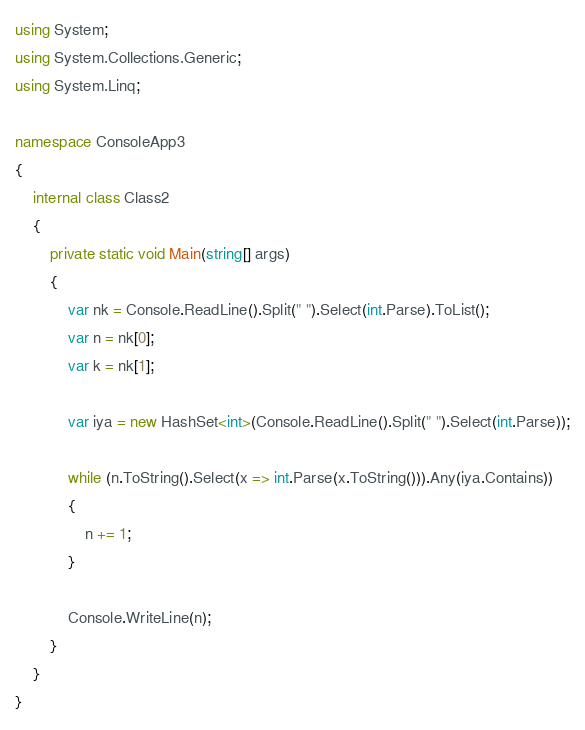<code> <loc_0><loc_0><loc_500><loc_500><_C#_>using System;
using System.Collections.Generic;
using System.Linq;

namespace ConsoleApp3
{
    internal class Class2
    {
        private static void Main(string[] args)
        {
            var nk = Console.ReadLine().Split(" ").Select(int.Parse).ToList();
            var n = nk[0];
            var k = nk[1];

            var iya = new HashSet<int>(Console.ReadLine().Split(" ").Select(int.Parse));

            while (n.ToString().Select(x => int.Parse(x.ToString())).Any(iya.Contains))
            {
                n += 1;
            }

            Console.WriteLine(n);
        }
    }
}</code> 